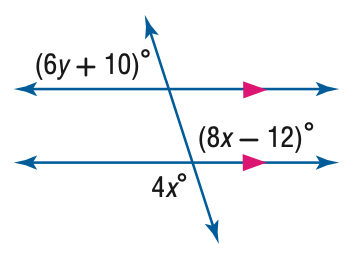Answer the mathemtical geometry problem and directly provide the correct option letter.
Question: Find y in the figure.
Choices: A: 12 B: 26.3 C: 28 D: 168 B 